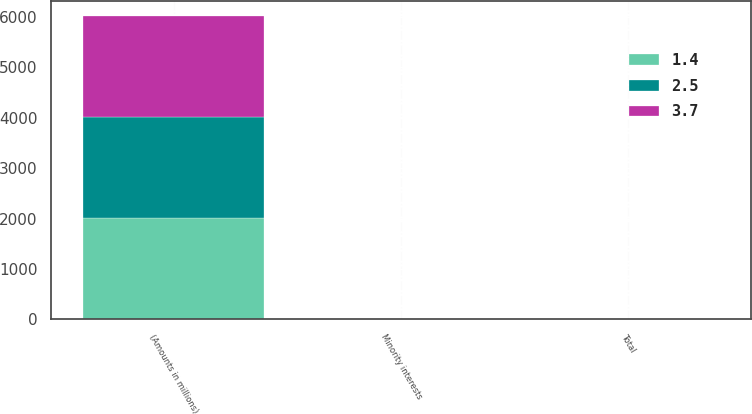Convert chart. <chart><loc_0><loc_0><loc_500><loc_500><stacked_bar_chart><ecel><fcel>(Amounts in millions)<fcel>Minority interests<fcel>Total<nl><fcel>3.7<fcel>2007<fcel>4.9<fcel>2.5<nl><fcel>2.5<fcel>2006<fcel>3.7<fcel>3.7<nl><fcel>1.4<fcel>2005<fcel>3.5<fcel>1.4<nl></chart> 